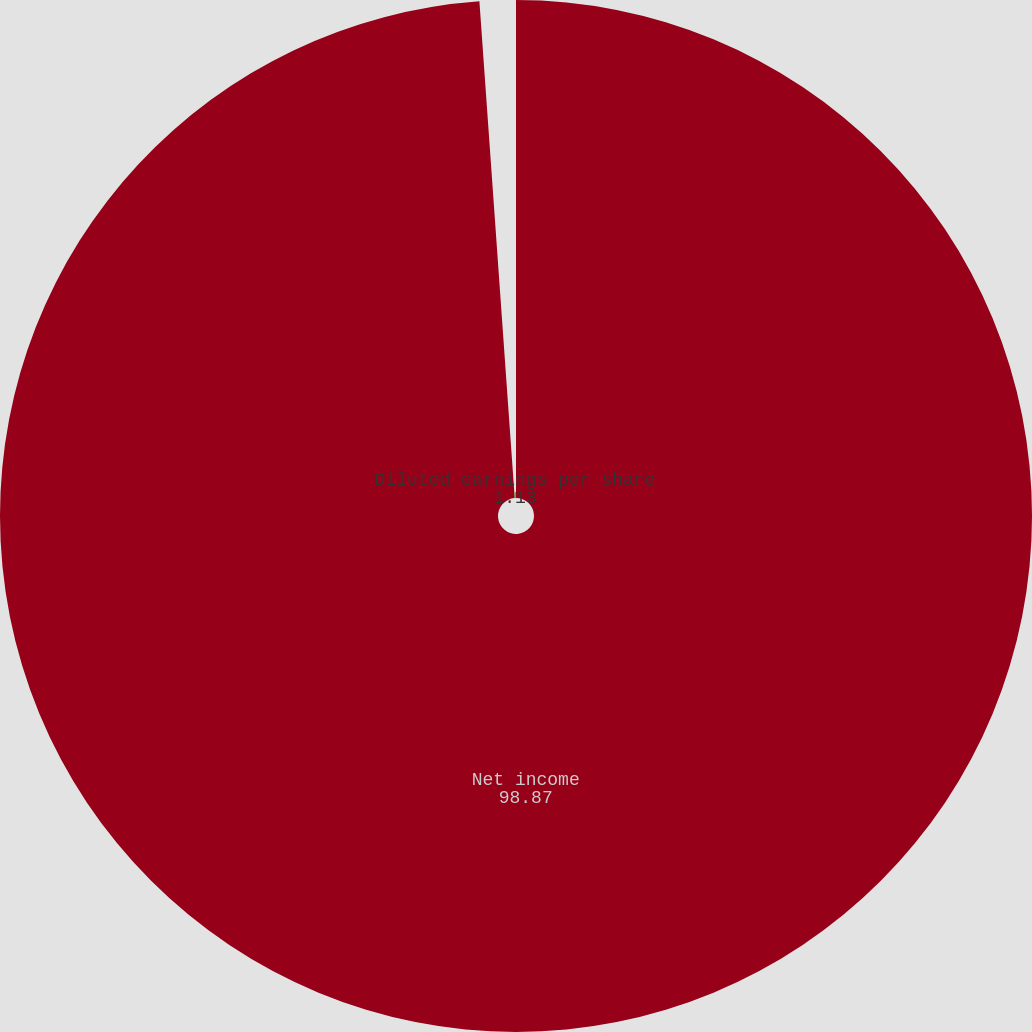<chart> <loc_0><loc_0><loc_500><loc_500><pie_chart><fcel>Net income<fcel>Diluted earnings per share<nl><fcel>98.87%<fcel>1.13%<nl></chart> 